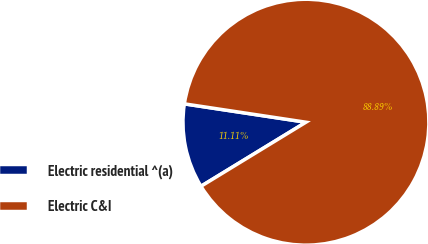Convert chart to OTSL. <chart><loc_0><loc_0><loc_500><loc_500><pie_chart><fcel>Electric residential ^(a)<fcel>Electric C&I<nl><fcel>11.11%<fcel>88.89%<nl></chart> 